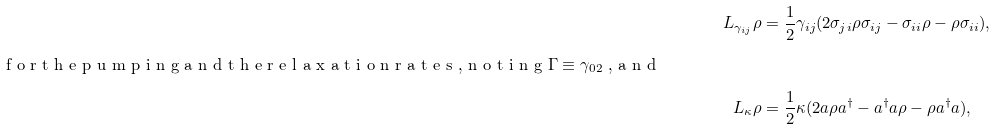<formula> <loc_0><loc_0><loc_500><loc_500>L _ { \gamma _ { i j } } \rho & = \frac { 1 } { 2 } \gamma _ { i j } ( 2 \sigma _ { j i } \rho \sigma _ { i j } - \sigma _ { i i } \rho - \rho \sigma _ { i i } ) , \\ \intertext { f o r t h e p u m p i n g a n d t h e r e l a x a t i o n r a t e s , n o t i n g $ \Gamma \equiv \gamma _ { 0 2 } $ , a n d } L _ { \kappa } \rho & = \frac { 1 } { 2 } \kappa ( 2 a \rho a ^ { \dag } - a ^ { \dag } a \rho - \rho a ^ { \dag } a ) ,</formula> 